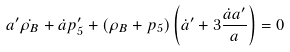Convert formula to latex. <formula><loc_0><loc_0><loc_500><loc_500>a ^ { \prime } \dot { \rho _ { B } } + \dot { a } p _ { 5 } ^ { \prime } + \left ( \rho _ { B } + p _ { 5 } \right ) \left ( \dot { a } ^ { \prime } + 3 \frac { \dot { a } a ^ { \prime } } { a } \right ) = 0</formula> 